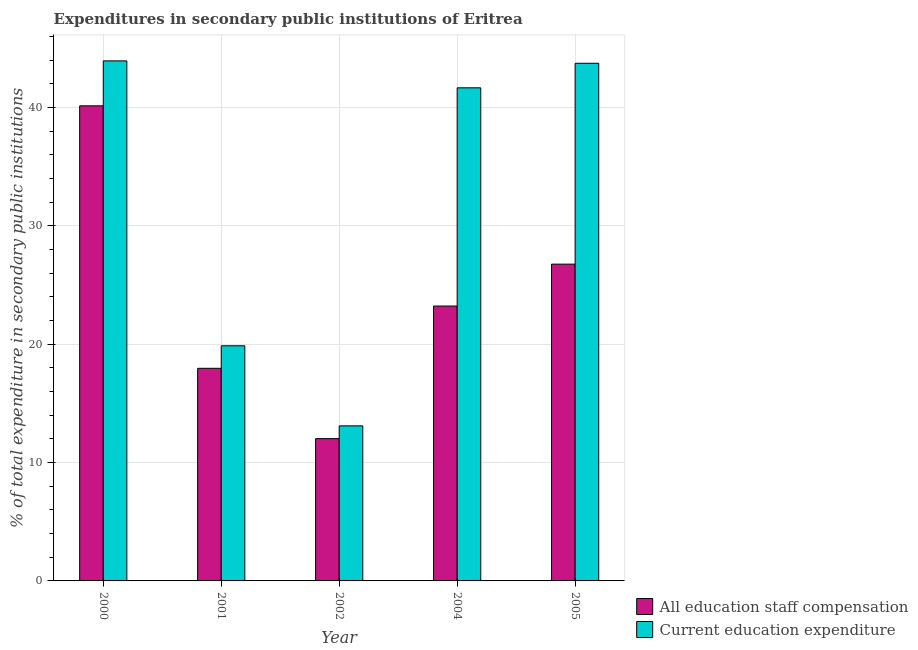How many groups of bars are there?
Your answer should be very brief. 5. Are the number of bars per tick equal to the number of legend labels?
Ensure brevity in your answer.  Yes. Are the number of bars on each tick of the X-axis equal?
Provide a succinct answer. Yes. How many bars are there on the 2nd tick from the right?
Your answer should be very brief. 2. What is the expenditure in staff compensation in 2005?
Make the answer very short. 26.76. Across all years, what is the maximum expenditure in staff compensation?
Your response must be concise. 40.13. Across all years, what is the minimum expenditure in education?
Give a very brief answer. 13.1. In which year was the expenditure in staff compensation maximum?
Make the answer very short. 2000. In which year was the expenditure in education minimum?
Ensure brevity in your answer.  2002. What is the total expenditure in staff compensation in the graph?
Ensure brevity in your answer.  120.08. What is the difference between the expenditure in staff compensation in 2000 and that in 2005?
Your response must be concise. 13.37. What is the difference between the expenditure in education in 2001 and the expenditure in staff compensation in 2002?
Offer a terse response. 6.76. What is the average expenditure in education per year?
Offer a terse response. 32.45. In the year 2005, what is the difference between the expenditure in education and expenditure in staff compensation?
Provide a succinct answer. 0. In how many years, is the expenditure in staff compensation greater than 30 %?
Provide a succinct answer. 1. What is the ratio of the expenditure in staff compensation in 2001 to that in 2002?
Ensure brevity in your answer.  1.49. What is the difference between the highest and the second highest expenditure in education?
Make the answer very short. 0.2. What is the difference between the highest and the lowest expenditure in education?
Ensure brevity in your answer.  30.83. Is the sum of the expenditure in education in 2000 and 2002 greater than the maximum expenditure in staff compensation across all years?
Make the answer very short. Yes. What does the 1st bar from the left in 2001 represents?
Offer a very short reply. All education staff compensation. What does the 2nd bar from the right in 2002 represents?
Give a very brief answer. All education staff compensation. How many bars are there?
Your answer should be very brief. 10. Are all the bars in the graph horizontal?
Your answer should be very brief. No. How many years are there in the graph?
Provide a succinct answer. 5. Are the values on the major ticks of Y-axis written in scientific E-notation?
Your answer should be very brief. No. Does the graph contain any zero values?
Your response must be concise. No. What is the title of the graph?
Your answer should be compact. Expenditures in secondary public institutions of Eritrea. Does "Residents" appear as one of the legend labels in the graph?
Ensure brevity in your answer.  No. What is the label or title of the Y-axis?
Your answer should be compact. % of total expenditure in secondary public institutions. What is the % of total expenditure in secondary public institutions of All education staff compensation in 2000?
Give a very brief answer. 40.13. What is the % of total expenditure in secondary public institutions of Current education expenditure in 2000?
Your answer should be very brief. 43.93. What is the % of total expenditure in secondary public institutions in All education staff compensation in 2001?
Offer a very short reply. 17.96. What is the % of total expenditure in secondary public institutions of Current education expenditure in 2001?
Your response must be concise. 19.86. What is the % of total expenditure in secondary public institutions of All education staff compensation in 2002?
Provide a short and direct response. 12.02. What is the % of total expenditure in secondary public institutions of Current education expenditure in 2002?
Give a very brief answer. 13.1. What is the % of total expenditure in secondary public institutions in All education staff compensation in 2004?
Offer a very short reply. 23.22. What is the % of total expenditure in secondary public institutions of Current education expenditure in 2004?
Provide a succinct answer. 41.65. What is the % of total expenditure in secondary public institutions of All education staff compensation in 2005?
Offer a very short reply. 26.76. What is the % of total expenditure in secondary public institutions in Current education expenditure in 2005?
Your answer should be compact. 43.72. Across all years, what is the maximum % of total expenditure in secondary public institutions of All education staff compensation?
Your answer should be compact. 40.13. Across all years, what is the maximum % of total expenditure in secondary public institutions of Current education expenditure?
Offer a terse response. 43.93. Across all years, what is the minimum % of total expenditure in secondary public institutions of All education staff compensation?
Offer a terse response. 12.02. Across all years, what is the minimum % of total expenditure in secondary public institutions of Current education expenditure?
Your answer should be very brief. 13.1. What is the total % of total expenditure in secondary public institutions of All education staff compensation in the graph?
Give a very brief answer. 120.08. What is the total % of total expenditure in secondary public institutions of Current education expenditure in the graph?
Your response must be concise. 162.26. What is the difference between the % of total expenditure in secondary public institutions of All education staff compensation in 2000 and that in 2001?
Ensure brevity in your answer.  22.17. What is the difference between the % of total expenditure in secondary public institutions of Current education expenditure in 2000 and that in 2001?
Your response must be concise. 24.07. What is the difference between the % of total expenditure in secondary public institutions of All education staff compensation in 2000 and that in 2002?
Offer a terse response. 28.11. What is the difference between the % of total expenditure in secondary public institutions of Current education expenditure in 2000 and that in 2002?
Make the answer very short. 30.83. What is the difference between the % of total expenditure in secondary public institutions in All education staff compensation in 2000 and that in 2004?
Your answer should be compact. 16.91. What is the difference between the % of total expenditure in secondary public institutions in Current education expenditure in 2000 and that in 2004?
Your answer should be very brief. 2.28. What is the difference between the % of total expenditure in secondary public institutions of All education staff compensation in 2000 and that in 2005?
Give a very brief answer. 13.37. What is the difference between the % of total expenditure in secondary public institutions in Current education expenditure in 2000 and that in 2005?
Provide a short and direct response. 0.2. What is the difference between the % of total expenditure in secondary public institutions in All education staff compensation in 2001 and that in 2002?
Keep it short and to the point. 5.94. What is the difference between the % of total expenditure in secondary public institutions of Current education expenditure in 2001 and that in 2002?
Keep it short and to the point. 6.76. What is the difference between the % of total expenditure in secondary public institutions of All education staff compensation in 2001 and that in 2004?
Give a very brief answer. -5.26. What is the difference between the % of total expenditure in secondary public institutions in Current education expenditure in 2001 and that in 2004?
Your answer should be compact. -21.79. What is the difference between the % of total expenditure in secondary public institutions of All education staff compensation in 2001 and that in 2005?
Your answer should be compact. -8.8. What is the difference between the % of total expenditure in secondary public institutions in Current education expenditure in 2001 and that in 2005?
Your answer should be very brief. -23.86. What is the difference between the % of total expenditure in secondary public institutions of All education staff compensation in 2002 and that in 2004?
Give a very brief answer. -11.2. What is the difference between the % of total expenditure in secondary public institutions of Current education expenditure in 2002 and that in 2004?
Give a very brief answer. -28.55. What is the difference between the % of total expenditure in secondary public institutions of All education staff compensation in 2002 and that in 2005?
Keep it short and to the point. -14.74. What is the difference between the % of total expenditure in secondary public institutions of Current education expenditure in 2002 and that in 2005?
Provide a short and direct response. -30.63. What is the difference between the % of total expenditure in secondary public institutions in All education staff compensation in 2004 and that in 2005?
Offer a terse response. -3.54. What is the difference between the % of total expenditure in secondary public institutions in Current education expenditure in 2004 and that in 2005?
Your answer should be compact. -2.07. What is the difference between the % of total expenditure in secondary public institutions in All education staff compensation in 2000 and the % of total expenditure in secondary public institutions in Current education expenditure in 2001?
Your response must be concise. 20.27. What is the difference between the % of total expenditure in secondary public institutions in All education staff compensation in 2000 and the % of total expenditure in secondary public institutions in Current education expenditure in 2002?
Offer a very short reply. 27.03. What is the difference between the % of total expenditure in secondary public institutions of All education staff compensation in 2000 and the % of total expenditure in secondary public institutions of Current education expenditure in 2004?
Your answer should be very brief. -1.52. What is the difference between the % of total expenditure in secondary public institutions of All education staff compensation in 2000 and the % of total expenditure in secondary public institutions of Current education expenditure in 2005?
Provide a short and direct response. -3.59. What is the difference between the % of total expenditure in secondary public institutions of All education staff compensation in 2001 and the % of total expenditure in secondary public institutions of Current education expenditure in 2002?
Keep it short and to the point. 4.86. What is the difference between the % of total expenditure in secondary public institutions in All education staff compensation in 2001 and the % of total expenditure in secondary public institutions in Current education expenditure in 2004?
Your answer should be very brief. -23.69. What is the difference between the % of total expenditure in secondary public institutions in All education staff compensation in 2001 and the % of total expenditure in secondary public institutions in Current education expenditure in 2005?
Ensure brevity in your answer.  -25.77. What is the difference between the % of total expenditure in secondary public institutions of All education staff compensation in 2002 and the % of total expenditure in secondary public institutions of Current education expenditure in 2004?
Keep it short and to the point. -29.63. What is the difference between the % of total expenditure in secondary public institutions of All education staff compensation in 2002 and the % of total expenditure in secondary public institutions of Current education expenditure in 2005?
Your answer should be very brief. -31.71. What is the difference between the % of total expenditure in secondary public institutions of All education staff compensation in 2004 and the % of total expenditure in secondary public institutions of Current education expenditure in 2005?
Your response must be concise. -20.51. What is the average % of total expenditure in secondary public institutions in All education staff compensation per year?
Offer a very short reply. 24.02. What is the average % of total expenditure in secondary public institutions of Current education expenditure per year?
Your response must be concise. 32.45. In the year 2000, what is the difference between the % of total expenditure in secondary public institutions of All education staff compensation and % of total expenditure in secondary public institutions of Current education expenditure?
Ensure brevity in your answer.  -3.8. In the year 2001, what is the difference between the % of total expenditure in secondary public institutions in All education staff compensation and % of total expenditure in secondary public institutions in Current education expenditure?
Your response must be concise. -1.9. In the year 2002, what is the difference between the % of total expenditure in secondary public institutions of All education staff compensation and % of total expenditure in secondary public institutions of Current education expenditure?
Offer a terse response. -1.08. In the year 2004, what is the difference between the % of total expenditure in secondary public institutions in All education staff compensation and % of total expenditure in secondary public institutions in Current education expenditure?
Offer a terse response. -18.43. In the year 2005, what is the difference between the % of total expenditure in secondary public institutions of All education staff compensation and % of total expenditure in secondary public institutions of Current education expenditure?
Your response must be concise. -16.97. What is the ratio of the % of total expenditure in secondary public institutions in All education staff compensation in 2000 to that in 2001?
Provide a short and direct response. 2.23. What is the ratio of the % of total expenditure in secondary public institutions of Current education expenditure in 2000 to that in 2001?
Your answer should be very brief. 2.21. What is the ratio of the % of total expenditure in secondary public institutions of All education staff compensation in 2000 to that in 2002?
Provide a succinct answer. 3.34. What is the ratio of the % of total expenditure in secondary public institutions in Current education expenditure in 2000 to that in 2002?
Make the answer very short. 3.35. What is the ratio of the % of total expenditure in secondary public institutions in All education staff compensation in 2000 to that in 2004?
Ensure brevity in your answer.  1.73. What is the ratio of the % of total expenditure in secondary public institutions in Current education expenditure in 2000 to that in 2004?
Give a very brief answer. 1.05. What is the ratio of the % of total expenditure in secondary public institutions of All education staff compensation in 2000 to that in 2005?
Offer a very short reply. 1.5. What is the ratio of the % of total expenditure in secondary public institutions of Current education expenditure in 2000 to that in 2005?
Ensure brevity in your answer.  1. What is the ratio of the % of total expenditure in secondary public institutions in All education staff compensation in 2001 to that in 2002?
Your answer should be very brief. 1.49. What is the ratio of the % of total expenditure in secondary public institutions in Current education expenditure in 2001 to that in 2002?
Ensure brevity in your answer.  1.52. What is the ratio of the % of total expenditure in secondary public institutions in All education staff compensation in 2001 to that in 2004?
Offer a terse response. 0.77. What is the ratio of the % of total expenditure in secondary public institutions of Current education expenditure in 2001 to that in 2004?
Your answer should be compact. 0.48. What is the ratio of the % of total expenditure in secondary public institutions in All education staff compensation in 2001 to that in 2005?
Provide a short and direct response. 0.67. What is the ratio of the % of total expenditure in secondary public institutions in Current education expenditure in 2001 to that in 2005?
Your answer should be very brief. 0.45. What is the ratio of the % of total expenditure in secondary public institutions of All education staff compensation in 2002 to that in 2004?
Offer a very short reply. 0.52. What is the ratio of the % of total expenditure in secondary public institutions of Current education expenditure in 2002 to that in 2004?
Offer a terse response. 0.31. What is the ratio of the % of total expenditure in secondary public institutions of All education staff compensation in 2002 to that in 2005?
Your response must be concise. 0.45. What is the ratio of the % of total expenditure in secondary public institutions in Current education expenditure in 2002 to that in 2005?
Provide a succinct answer. 0.3. What is the ratio of the % of total expenditure in secondary public institutions in All education staff compensation in 2004 to that in 2005?
Provide a succinct answer. 0.87. What is the ratio of the % of total expenditure in secondary public institutions of Current education expenditure in 2004 to that in 2005?
Make the answer very short. 0.95. What is the difference between the highest and the second highest % of total expenditure in secondary public institutions in All education staff compensation?
Your answer should be compact. 13.37. What is the difference between the highest and the second highest % of total expenditure in secondary public institutions of Current education expenditure?
Give a very brief answer. 0.2. What is the difference between the highest and the lowest % of total expenditure in secondary public institutions of All education staff compensation?
Ensure brevity in your answer.  28.11. What is the difference between the highest and the lowest % of total expenditure in secondary public institutions of Current education expenditure?
Provide a succinct answer. 30.83. 